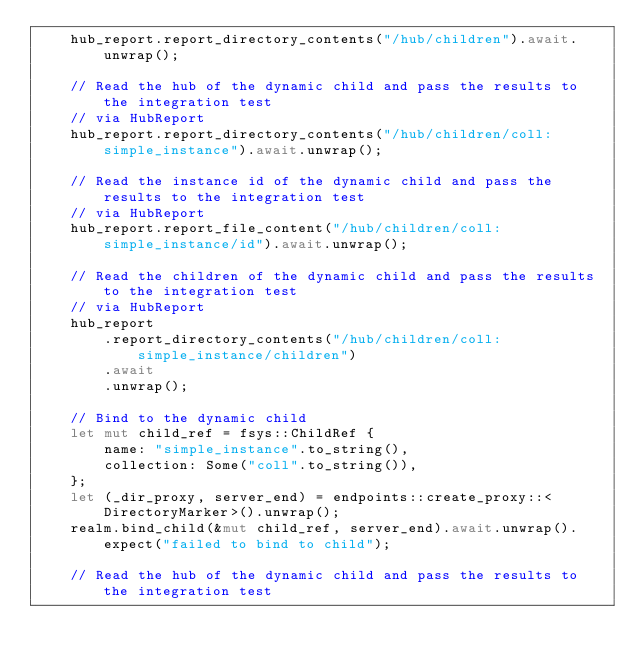<code> <loc_0><loc_0><loc_500><loc_500><_Rust_>    hub_report.report_directory_contents("/hub/children").await.unwrap();

    // Read the hub of the dynamic child and pass the results to the integration test
    // via HubReport
    hub_report.report_directory_contents("/hub/children/coll:simple_instance").await.unwrap();

    // Read the instance id of the dynamic child and pass the results to the integration test
    // via HubReport
    hub_report.report_file_content("/hub/children/coll:simple_instance/id").await.unwrap();

    // Read the children of the dynamic child and pass the results to the integration test
    // via HubReport
    hub_report
        .report_directory_contents("/hub/children/coll:simple_instance/children")
        .await
        .unwrap();

    // Bind to the dynamic child
    let mut child_ref = fsys::ChildRef {
        name: "simple_instance".to_string(),
        collection: Some("coll".to_string()),
    };
    let (_dir_proxy, server_end) = endpoints::create_proxy::<DirectoryMarker>().unwrap();
    realm.bind_child(&mut child_ref, server_end).await.unwrap().expect("failed to bind to child");

    // Read the hub of the dynamic child and pass the results to the integration test</code> 